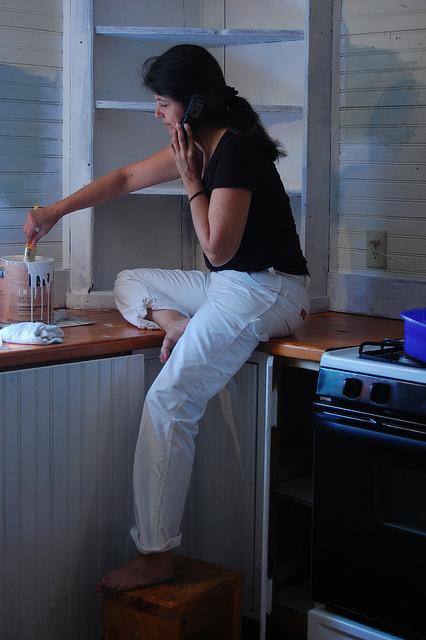Is the kitchen clean?
Be succinct. Yes. Is the woman painting?
Concise answer only. Yes. Which foot is on a stool?
Quick response, please. Left. 